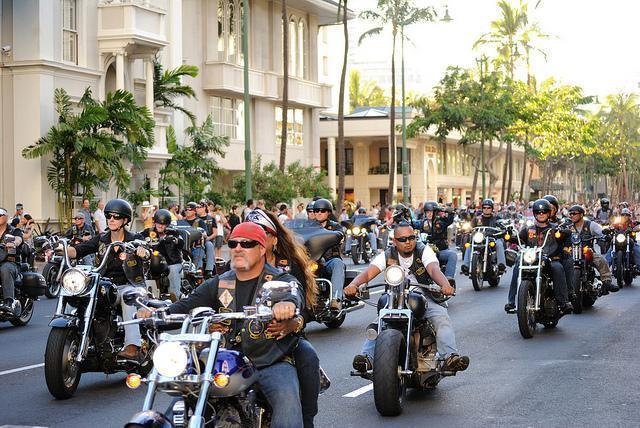What is the main reason hundreds of bikers would be riding together down a main street?
Choose the correct response, then elucidate: 'Answer: answer
Rationale: rationale.'
Options: Conserve gas, safest route, short cut, attention. Answer: attention.
Rationale: The reason is for attention. 